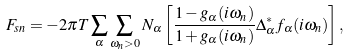<formula> <loc_0><loc_0><loc_500><loc_500>F _ { s n } = - 2 \pi T \sum _ { \alpha } \sum _ { \omega _ { n } > 0 } N _ { \alpha } \left [ \frac { 1 - g _ { \alpha } ( i \omega _ { n } ) } { 1 + g _ { \alpha } ( i \omega _ { n } ) } \Delta _ { \alpha } ^ { \ast } f _ { \alpha } ( i \omega _ { n } ) \right ] ,</formula> 